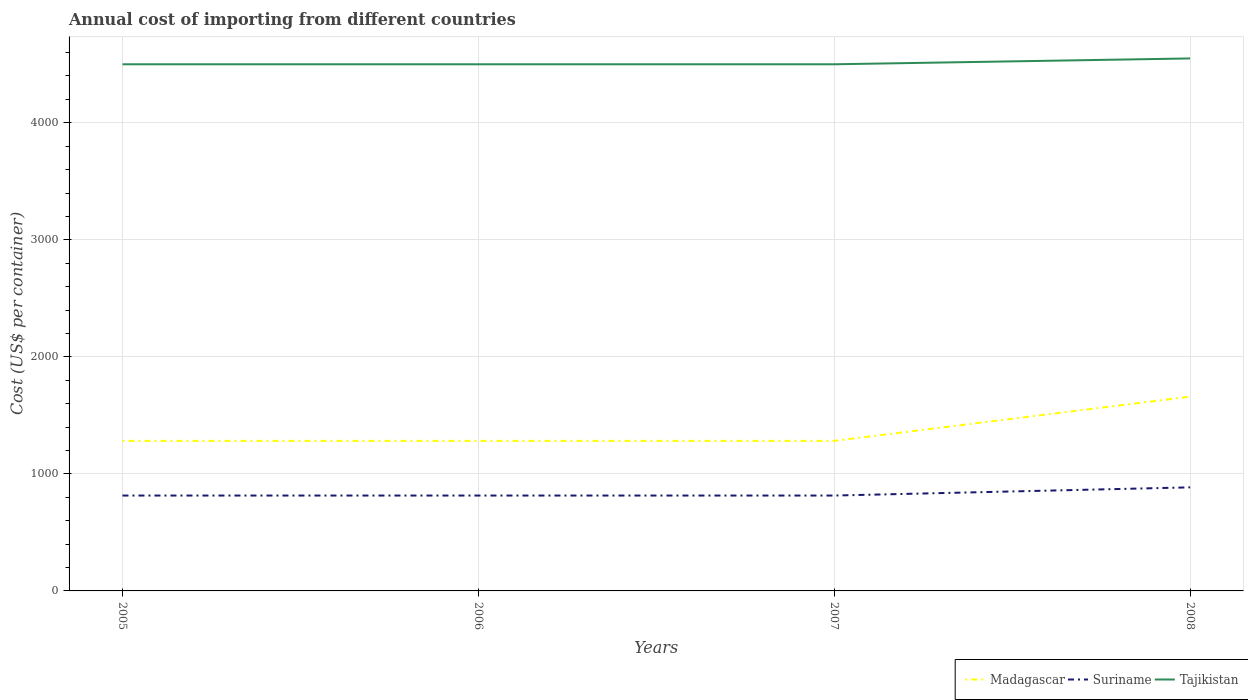How many different coloured lines are there?
Keep it short and to the point. 3. Across all years, what is the maximum total annual cost of importing in Madagascar?
Keep it short and to the point. 1282. In which year was the total annual cost of importing in Tajikistan maximum?
Make the answer very short. 2005. What is the total total annual cost of importing in Suriname in the graph?
Ensure brevity in your answer.  0. What is the difference between the highest and the second highest total annual cost of importing in Suriname?
Make the answer very short. 70. Is the total annual cost of importing in Suriname strictly greater than the total annual cost of importing in Madagascar over the years?
Your answer should be very brief. Yes. How many years are there in the graph?
Your response must be concise. 4. What is the difference between two consecutive major ticks on the Y-axis?
Your response must be concise. 1000. Are the values on the major ticks of Y-axis written in scientific E-notation?
Offer a terse response. No. Does the graph contain grids?
Make the answer very short. Yes. How are the legend labels stacked?
Offer a terse response. Horizontal. What is the title of the graph?
Make the answer very short. Annual cost of importing from different countries. What is the label or title of the X-axis?
Ensure brevity in your answer.  Years. What is the label or title of the Y-axis?
Offer a terse response. Cost (US$ per container). What is the Cost (US$ per container) in Madagascar in 2005?
Keep it short and to the point. 1282. What is the Cost (US$ per container) of Suriname in 2005?
Your response must be concise. 815. What is the Cost (US$ per container) of Tajikistan in 2005?
Your answer should be very brief. 4500. What is the Cost (US$ per container) in Madagascar in 2006?
Offer a terse response. 1282. What is the Cost (US$ per container) of Suriname in 2006?
Provide a succinct answer. 815. What is the Cost (US$ per container) in Tajikistan in 2006?
Offer a terse response. 4500. What is the Cost (US$ per container) of Madagascar in 2007?
Your answer should be compact. 1282. What is the Cost (US$ per container) in Suriname in 2007?
Your answer should be very brief. 815. What is the Cost (US$ per container) in Tajikistan in 2007?
Offer a terse response. 4500. What is the Cost (US$ per container) of Madagascar in 2008?
Provide a short and direct response. 1660. What is the Cost (US$ per container) of Suriname in 2008?
Your answer should be very brief. 885. What is the Cost (US$ per container) in Tajikistan in 2008?
Offer a terse response. 4550. Across all years, what is the maximum Cost (US$ per container) in Madagascar?
Your answer should be very brief. 1660. Across all years, what is the maximum Cost (US$ per container) of Suriname?
Offer a terse response. 885. Across all years, what is the maximum Cost (US$ per container) of Tajikistan?
Make the answer very short. 4550. Across all years, what is the minimum Cost (US$ per container) of Madagascar?
Ensure brevity in your answer.  1282. Across all years, what is the minimum Cost (US$ per container) in Suriname?
Provide a succinct answer. 815. Across all years, what is the minimum Cost (US$ per container) of Tajikistan?
Offer a terse response. 4500. What is the total Cost (US$ per container) in Madagascar in the graph?
Provide a short and direct response. 5506. What is the total Cost (US$ per container) of Suriname in the graph?
Ensure brevity in your answer.  3330. What is the total Cost (US$ per container) of Tajikistan in the graph?
Your answer should be compact. 1.80e+04. What is the difference between the Cost (US$ per container) of Madagascar in 2005 and that in 2006?
Provide a short and direct response. 0. What is the difference between the Cost (US$ per container) in Tajikistan in 2005 and that in 2006?
Offer a terse response. 0. What is the difference between the Cost (US$ per container) of Madagascar in 2005 and that in 2008?
Make the answer very short. -378. What is the difference between the Cost (US$ per container) of Suriname in 2005 and that in 2008?
Provide a succinct answer. -70. What is the difference between the Cost (US$ per container) in Tajikistan in 2005 and that in 2008?
Give a very brief answer. -50. What is the difference between the Cost (US$ per container) of Tajikistan in 2006 and that in 2007?
Offer a terse response. 0. What is the difference between the Cost (US$ per container) of Madagascar in 2006 and that in 2008?
Offer a very short reply. -378. What is the difference between the Cost (US$ per container) of Suriname in 2006 and that in 2008?
Your answer should be very brief. -70. What is the difference between the Cost (US$ per container) in Madagascar in 2007 and that in 2008?
Your answer should be very brief. -378. What is the difference between the Cost (US$ per container) in Suriname in 2007 and that in 2008?
Keep it short and to the point. -70. What is the difference between the Cost (US$ per container) of Tajikistan in 2007 and that in 2008?
Keep it short and to the point. -50. What is the difference between the Cost (US$ per container) in Madagascar in 2005 and the Cost (US$ per container) in Suriname in 2006?
Your answer should be compact. 467. What is the difference between the Cost (US$ per container) in Madagascar in 2005 and the Cost (US$ per container) in Tajikistan in 2006?
Ensure brevity in your answer.  -3218. What is the difference between the Cost (US$ per container) in Suriname in 2005 and the Cost (US$ per container) in Tajikistan in 2006?
Make the answer very short. -3685. What is the difference between the Cost (US$ per container) in Madagascar in 2005 and the Cost (US$ per container) in Suriname in 2007?
Provide a short and direct response. 467. What is the difference between the Cost (US$ per container) in Madagascar in 2005 and the Cost (US$ per container) in Tajikistan in 2007?
Your answer should be very brief. -3218. What is the difference between the Cost (US$ per container) in Suriname in 2005 and the Cost (US$ per container) in Tajikistan in 2007?
Offer a very short reply. -3685. What is the difference between the Cost (US$ per container) of Madagascar in 2005 and the Cost (US$ per container) of Suriname in 2008?
Your answer should be compact. 397. What is the difference between the Cost (US$ per container) of Madagascar in 2005 and the Cost (US$ per container) of Tajikistan in 2008?
Make the answer very short. -3268. What is the difference between the Cost (US$ per container) of Suriname in 2005 and the Cost (US$ per container) of Tajikistan in 2008?
Offer a terse response. -3735. What is the difference between the Cost (US$ per container) in Madagascar in 2006 and the Cost (US$ per container) in Suriname in 2007?
Your response must be concise. 467. What is the difference between the Cost (US$ per container) in Madagascar in 2006 and the Cost (US$ per container) in Tajikistan in 2007?
Offer a very short reply. -3218. What is the difference between the Cost (US$ per container) in Suriname in 2006 and the Cost (US$ per container) in Tajikistan in 2007?
Provide a succinct answer. -3685. What is the difference between the Cost (US$ per container) of Madagascar in 2006 and the Cost (US$ per container) of Suriname in 2008?
Keep it short and to the point. 397. What is the difference between the Cost (US$ per container) of Madagascar in 2006 and the Cost (US$ per container) of Tajikistan in 2008?
Ensure brevity in your answer.  -3268. What is the difference between the Cost (US$ per container) in Suriname in 2006 and the Cost (US$ per container) in Tajikistan in 2008?
Offer a terse response. -3735. What is the difference between the Cost (US$ per container) in Madagascar in 2007 and the Cost (US$ per container) in Suriname in 2008?
Offer a very short reply. 397. What is the difference between the Cost (US$ per container) of Madagascar in 2007 and the Cost (US$ per container) of Tajikistan in 2008?
Your answer should be compact. -3268. What is the difference between the Cost (US$ per container) in Suriname in 2007 and the Cost (US$ per container) in Tajikistan in 2008?
Give a very brief answer. -3735. What is the average Cost (US$ per container) in Madagascar per year?
Provide a succinct answer. 1376.5. What is the average Cost (US$ per container) of Suriname per year?
Give a very brief answer. 832.5. What is the average Cost (US$ per container) of Tajikistan per year?
Ensure brevity in your answer.  4512.5. In the year 2005, what is the difference between the Cost (US$ per container) of Madagascar and Cost (US$ per container) of Suriname?
Provide a short and direct response. 467. In the year 2005, what is the difference between the Cost (US$ per container) of Madagascar and Cost (US$ per container) of Tajikistan?
Your answer should be compact. -3218. In the year 2005, what is the difference between the Cost (US$ per container) in Suriname and Cost (US$ per container) in Tajikistan?
Provide a short and direct response. -3685. In the year 2006, what is the difference between the Cost (US$ per container) in Madagascar and Cost (US$ per container) in Suriname?
Your response must be concise. 467. In the year 2006, what is the difference between the Cost (US$ per container) of Madagascar and Cost (US$ per container) of Tajikistan?
Provide a short and direct response. -3218. In the year 2006, what is the difference between the Cost (US$ per container) of Suriname and Cost (US$ per container) of Tajikistan?
Give a very brief answer. -3685. In the year 2007, what is the difference between the Cost (US$ per container) in Madagascar and Cost (US$ per container) in Suriname?
Your response must be concise. 467. In the year 2007, what is the difference between the Cost (US$ per container) of Madagascar and Cost (US$ per container) of Tajikistan?
Your answer should be very brief. -3218. In the year 2007, what is the difference between the Cost (US$ per container) of Suriname and Cost (US$ per container) of Tajikistan?
Keep it short and to the point. -3685. In the year 2008, what is the difference between the Cost (US$ per container) of Madagascar and Cost (US$ per container) of Suriname?
Your response must be concise. 775. In the year 2008, what is the difference between the Cost (US$ per container) of Madagascar and Cost (US$ per container) of Tajikistan?
Give a very brief answer. -2890. In the year 2008, what is the difference between the Cost (US$ per container) of Suriname and Cost (US$ per container) of Tajikistan?
Provide a succinct answer. -3665. What is the ratio of the Cost (US$ per container) of Madagascar in 2005 to that in 2006?
Your answer should be very brief. 1. What is the ratio of the Cost (US$ per container) of Suriname in 2005 to that in 2006?
Provide a succinct answer. 1. What is the ratio of the Cost (US$ per container) of Tajikistan in 2005 to that in 2006?
Offer a very short reply. 1. What is the ratio of the Cost (US$ per container) of Suriname in 2005 to that in 2007?
Ensure brevity in your answer.  1. What is the ratio of the Cost (US$ per container) in Madagascar in 2005 to that in 2008?
Keep it short and to the point. 0.77. What is the ratio of the Cost (US$ per container) in Suriname in 2005 to that in 2008?
Offer a very short reply. 0.92. What is the ratio of the Cost (US$ per container) of Madagascar in 2006 to that in 2007?
Offer a terse response. 1. What is the ratio of the Cost (US$ per container) in Suriname in 2006 to that in 2007?
Offer a terse response. 1. What is the ratio of the Cost (US$ per container) of Tajikistan in 2006 to that in 2007?
Provide a succinct answer. 1. What is the ratio of the Cost (US$ per container) in Madagascar in 2006 to that in 2008?
Provide a short and direct response. 0.77. What is the ratio of the Cost (US$ per container) in Suriname in 2006 to that in 2008?
Your answer should be compact. 0.92. What is the ratio of the Cost (US$ per container) of Tajikistan in 2006 to that in 2008?
Ensure brevity in your answer.  0.99. What is the ratio of the Cost (US$ per container) of Madagascar in 2007 to that in 2008?
Ensure brevity in your answer.  0.77. What is the ratio of the Cost (US$ per container) in Suriname in 2007 to that in 2008?
Your answer should be compact. 0.92. What is the ratio of the Cost (US$ per container) in Tajikistan in 2007 to that in 2008?
Ensure brevity in your answer.  0.99. What is the difference between the highest and the second highest Cost (US$ per container) in Madagascar?
Make the answer very short. 378. What is the difference between the highest and the lowest Cost (US$ per container) in Madagascar?
Keep it short and to the point. 378. What is the difference between the highest and the lowest Cost (US$ per container) of Tajikistan?
Keep it short and to the point. 50. 